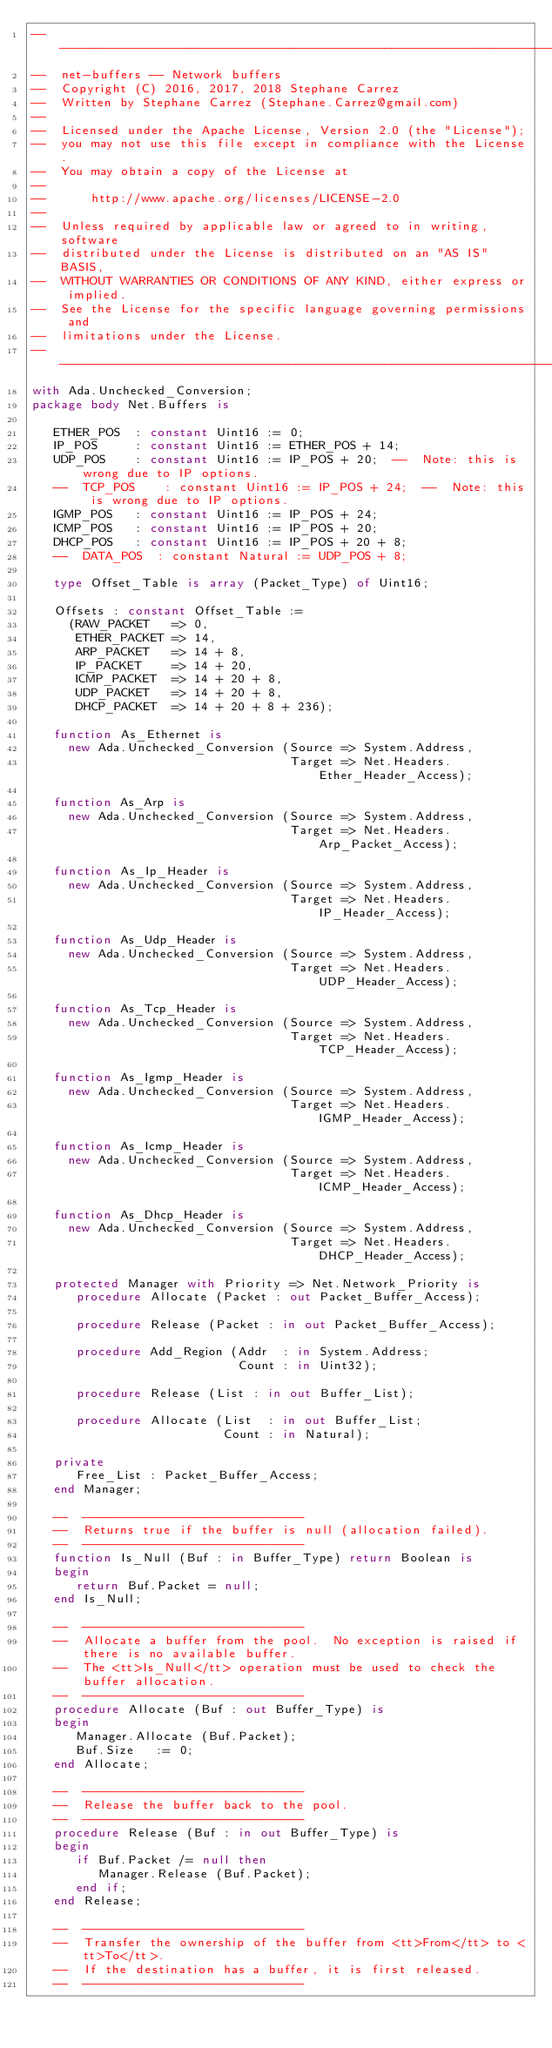Convert code to text. <code><loc_0><loc_0><loc_500><loc_500><_Ada_>-----------------------------------------------------------------------
--  net-buffers -- Network buffers
--  Copyright (C) 2016, 2017, 2018 Stephane Carrez
--  Written by Stephane Carrez (Stephane.Carrez@gmail.com)
--
--  Licensed under the Apache License, Version 2.0 (the "License");
--  you may not use this file except in compliance with the License.
--  You may obtain a copy of the License at
--
--      http://www.apache.org/licenses/LICENSE-2.0
--
--  Unless required by applicable law or agreed to in writing, software
--  distributed under the License is distributed on an "AS IS" BASIS,
--  WITHOUT WARRANTIES OR CONDITIONS OF ANY KIND, either express or implied.
--  See the License for the specific language governing permissions and
--  limitations under the License.
-----------------------------------------------------------------------
with Ada.Unchecked_Conversion;
package body Net.Buffers is

   ETHER_POS  : constant Uint16 := 0;
   IP_POS     : constant Uint16 := ETHER_POS + 14;
   UDP_POS    : constant Uint16 := IP_POS + 20;  --  Note: this is wrong due to IP options.
   --  TCP_POS    : constant Uint16 := IP_POS + 24;  --  Note: this is wrong due to IP options.
   IGMP_POS   : constant Uint16 := IP_POS + 24;
   ICMP_POS   : constant Uint16 := IP_POS + 20;
   DHCP_POS   : constant Uint16 := IP_POS + 20 + 8;
   --  DATA_POS  : constant Natural := UDP_POS + 8;

   type Offset_Table is array (Packet_Type) of Uint16;

   Offsets : constant Offset_Table :=
     (RAW_PACKET   => 0,
      ETHER_PACKET => 14,
      ARP_PACKET   => 14 + 8,
      IP_PACKET    => 14 + 20,
      ICMP_PACKET  => 14 + 20 + 8,
      UDP_PACKET   => 14 + 20 + 8,
      DHCP_PACKET  => 14 + 20 + 8 + 236);

   function As_Ethernet is
     new Ada.Unchecked_Conversion (Source => System.Address,
                                   Target => Net.Headers.Ether_Header_Access);

   function As_Arp is
     new Ada.Unchecked_Conversion (Source => System.Address,
                                   Target => Net.Headers.Arp_Packet_Access);

   function As_Ip_Header is
     new Ada.Unchecked_Conversion (Source => System.Address,
                                   Target => Net.Headers.IP_Header_Access);

   function As_Udp_Header is
     new Ada.Unchecked_Conversion (Source => System.Address,
                                   Target => Net.Headers.UDP_Header_Access);

   function As_Tcp_Header is
     new Ada.Unchecked_Conversion (Source => System.Address,
                                   Target => Net.Headers.TCP_Header_Access);

   function As_Igmp_Header is
     new Ada.Unchecked_Conversion (Source => System.Address,
                                   Target => Net.Headers.IGMP_Header_Access);

   function As_Icmp_Header is
     new Ada.Unchecked_Conversion (Source => System.Address,
                                   Target => Net.Headers.ICMP_Header_Access);

   function As_Dhcp_Header is
     new Ada.Unchecked_Conversion (Source => System.Address,
                                   Target => Net.Headers.DHCP_Header_Access);

   protected Manager with Priority => Net.Network_Priority is
      procedure Allocate (Packet : out Packet_Buffer_Access);

      procedure Release (Packet : in out Packet_Buffer_Access);

      procedure Add_Region (Addr  : in System.Address;
                            Count : in Uint32);

      procedure Release (List : in out Buffer_List);

      procedure Allocate (List  : in out Buffer_List;
                          Count : in Natural);

   private
      Free_List : Packet_Buffer_Access;
   end Manager;

   --  ------------------------------
   --  Returns true if the buffer is null (allocation failed).
   --  ------------------------------
   function Is_Null (Buf : in Buffer_Type) return Boolean is
   begin
      return Buf.Packet = null;
   end Is_Null;

   --  ------------------------------
   --  Allocate a buffer from the pool.  No exception is raised if there is no available buffer.
   --  The <tt>Is_Null</tt> operation must be used to check the buffer allocation.
   --  ------------------------------
   procedure Allocate (Buf : out Buffer_Type) is
   begin
      Manager.Allocate (Buf.Packet);
      Buf.Size   := 0;
   end Allocate;

   --  ------------------------------
   --  Release the buffer back to the pool.
   --  ------------------------------
   procedure Release (Buf : in out Buffer_Type) is
   begin
      if Buf.Packet /= null then
         Manager.Release (Buf.Packet);
      end if;
   end Release;

   --  ------------------------------
   --  Transfer the ownership of the buffer from <tt>From</tt> to <tt>To</tt>.
   --  If the destination has a buffer, it is first released.
   --  ------------------------------</code> 